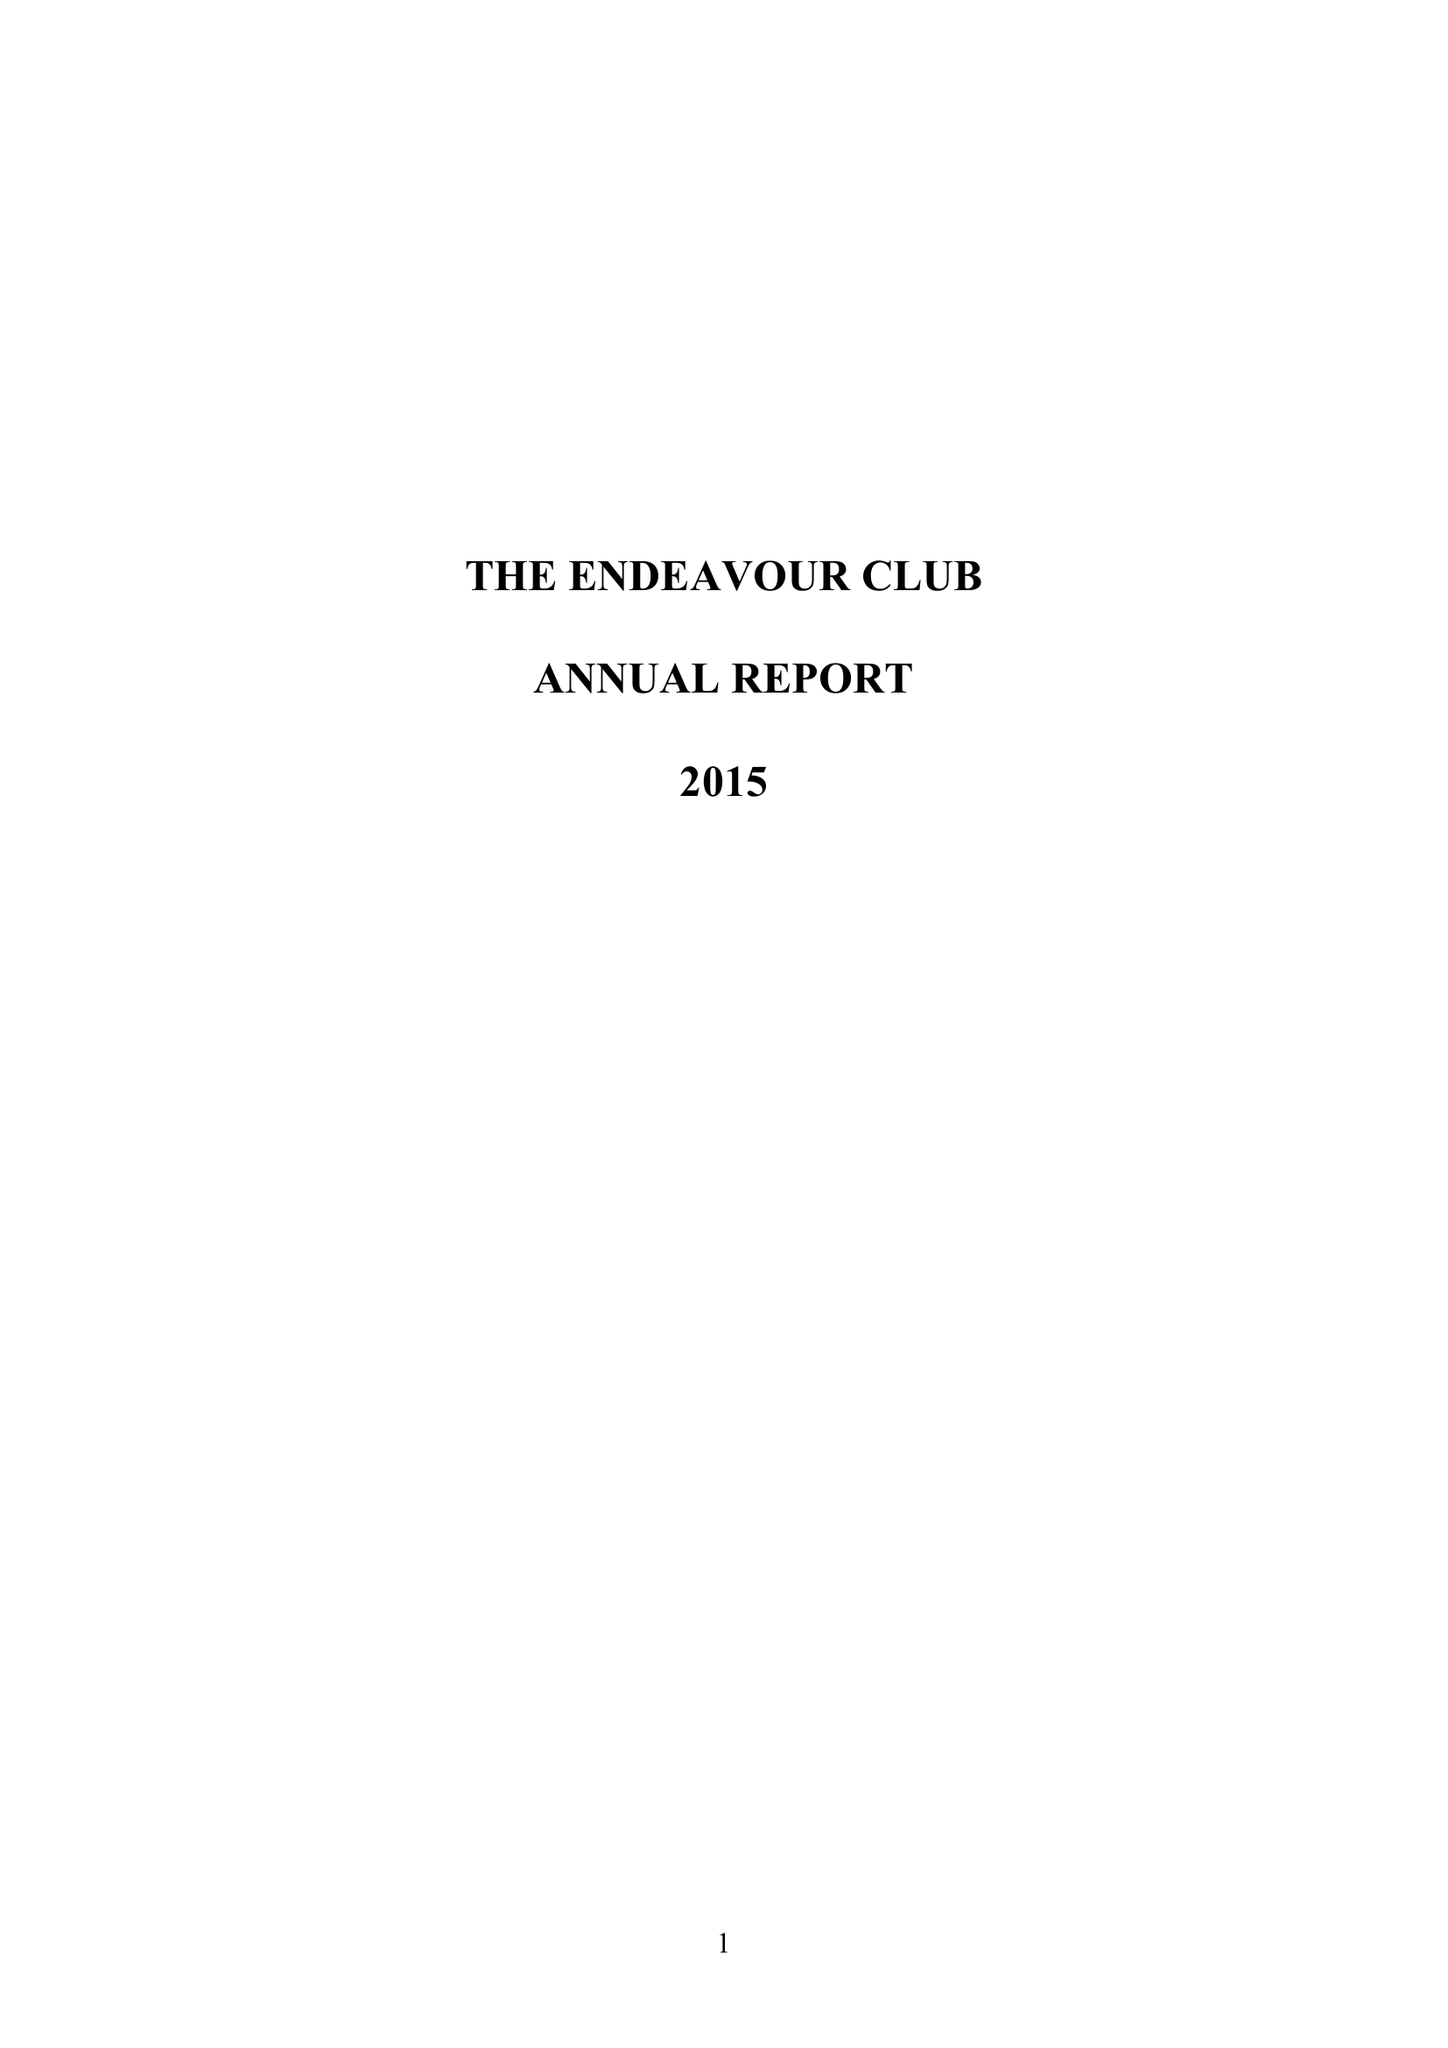What is the value for the report_date?
Answer the question using a single word or phrase. 2015-12-31 